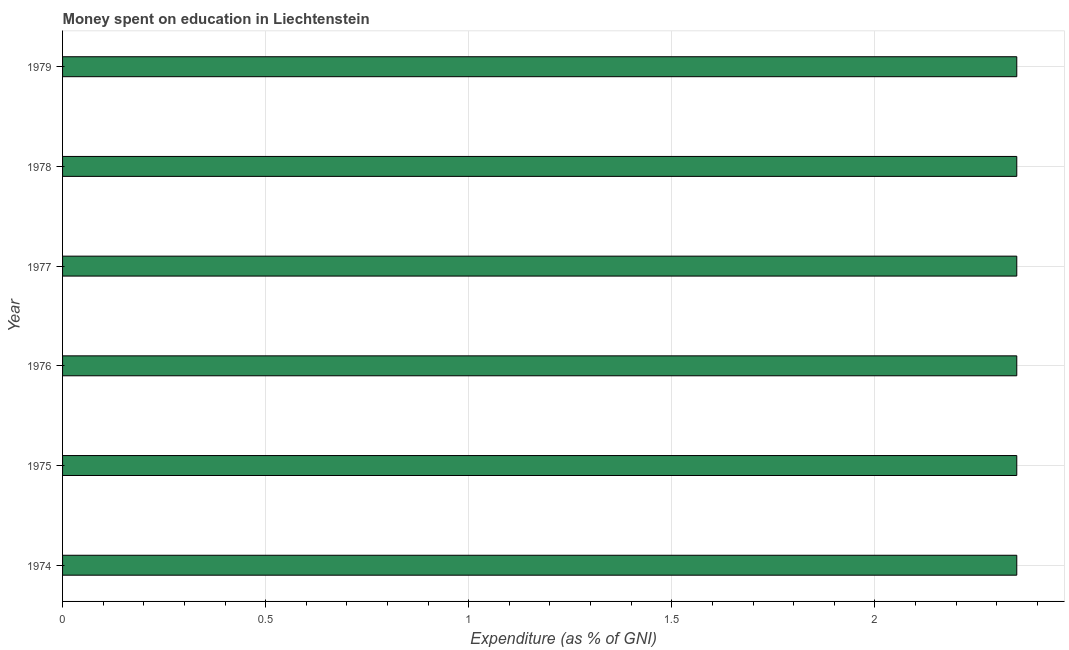Does the graph contain any zero values?
Provide a succinct answer. No. Does the graph contain grids?
Your response must be concise. Yes. What is the title of the graph?
Your answer should be compact. Money spent on education in Liechtenstein. What is the label or title of the X-axis?
Your answer should be very brief. Expenditure (as % of GNI). What is the label or title of the Y-axis?
Ensure brevity in your answer.  Year. What is the expenditure on education in 1974?
Provide a succinct answer. 2.35. Across all years, what is the maximum expenditure on education?
Keep it short and to the point. 2.35. Across all years, what is the minimum expenditure on education?
Your response must be concise. 2.35. In which year was the expenditure on education maximum?
Your answer should be very brief. 1974. In which year was the expenditure on education minimum?
Your answer should be compact. 1974. What is the sum of the expenditure on education?
Provide a succinct answer. 14.1. What is the average expenditure on education per year?
Make the answer very short. 2.35. What is the median expenditure on education?
Make the answer very short. 2.35. Is the expenditure on education in 1974 less than that in 1979?
Provide a succinct answer. No. Is the difference between the expenditure on education in 1976 and 1977 greater than the difference between any two years?
Keep it short and to the point. Yes. How many bars are there?
Your answer should be compact. 6. What is the difference between two consecutive major ticks on the X-axis?
Your answer should be compact. 0.5. What is the Expenditure (as % of GNI) in 1974?
Your answer should be compact. 2.35. What is the Expenditure (as % of GNI) of 1975?
Offer a terse response. 2.35. What is the Expenditure (as % of GNI) in 1976?
Keep it short and to the point. 2.35. What is the Expenditure (as % of GNI) in 1977?
Offer a very short reply. 2.35. What is the Expenditure (as % of GNI) of 1978?
Your answer should be compact. 2.35. What is the Expenditure (as % of GNI) in 1979?
Your response must be concise. 2.35. What is the difference between the Expenditure (as % of GNI) in 1974 and 1975?
Give a very brief answer. 0. What is the difference between the Expenditure (as % of GNI) in 1974 and 1978?
Offer a very short reply. 0. What is the difference between the Expenditure (as % of GNI) in 1974 and 1979?
Your response must be concise. 0. What is the difference between the Expenditure (as % of GNI) in 1975 and 1976?
Offer a very short reply. 0. What is the difference between the Expenditure (as % of GNI) in 1975 and 1977?
Provide a short and direct response. 0. What is the difference between the Expenditure (as % of GNI) in 1976 and 1977?
Make the answer very short. 0. What is the difference between the Expenditure (as % of GNI) in 1976 and 1978?
Offer a very short reply. 0. What is the difference between the Expenditure (as % of GNI) in 1976 and 1979?
Offer a terse response. 0. What is the difference between the Expenditure (as % of GNI) in 1977 and 1978?
Your answer should be compact. 0. What is the difference between the Expenditure (as % of GNI) in 1977 and 1979?
Your answer should be very brief. 0. What is the difference between the Expenditure (as % of GNI) in 1978 and 1979?
Provide a short and direct response. 0. What is the ratio of the Expenditure (as % of GNI) in 1974 to that in 1977?
Your response must be concise. 1. What is the ratio of the Expenditure (as % of GNI) in 1974 to that in 1978?
Your answer should be very brief. 1. What is the ratio of the Expenditure (as % of GNI) in 1975 to that in 1977?
Offer a very short reply. 1. What is the ratio of the Expenditure (as % of GNI) in 1975 to that in 1979?
Your answer should be very brief. 1. What is the ratio of the Expenditure (as % of GNI) in 1978 to that in 1979?
Offer a terse response. 1. 